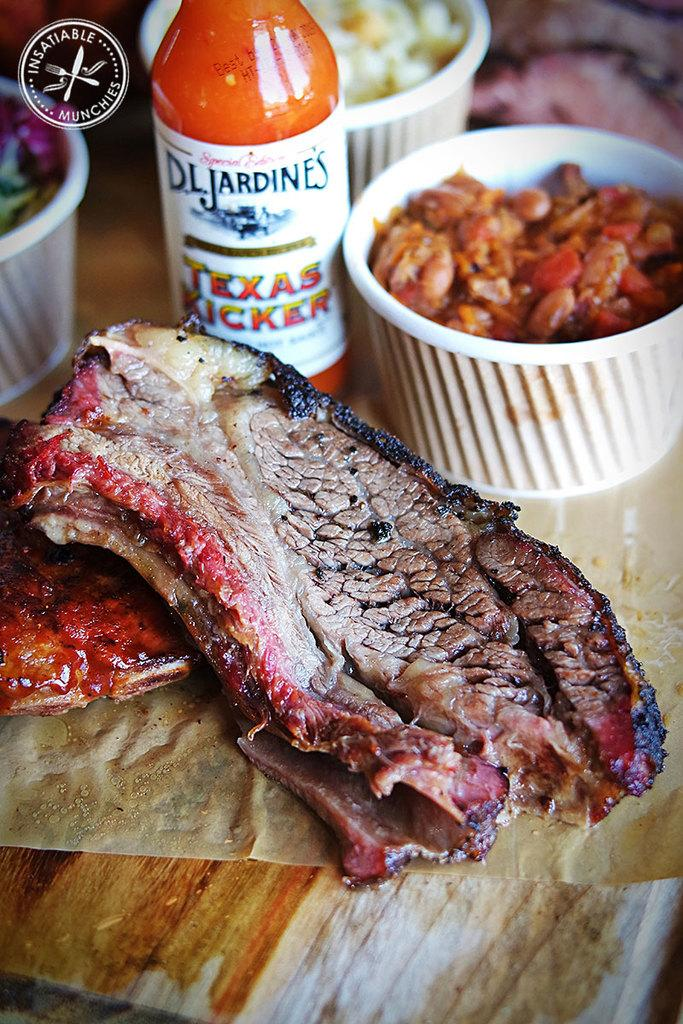What is present on the table in the image? There are food items on a table in the image. Can you describe the type of meat on the table? There is a piece of meat on the table. How many bowls of other food items are on the table? There are three bowls of other food items on the table. What else can be seen on the table besides the food items? There is a bottle on the table. Can you tell me what type of ocean is visible in the background of the image? There is no ocean visible in the image; it only shows a table with food items, a piece of meat, three bowls of other food items, and a bottle. 